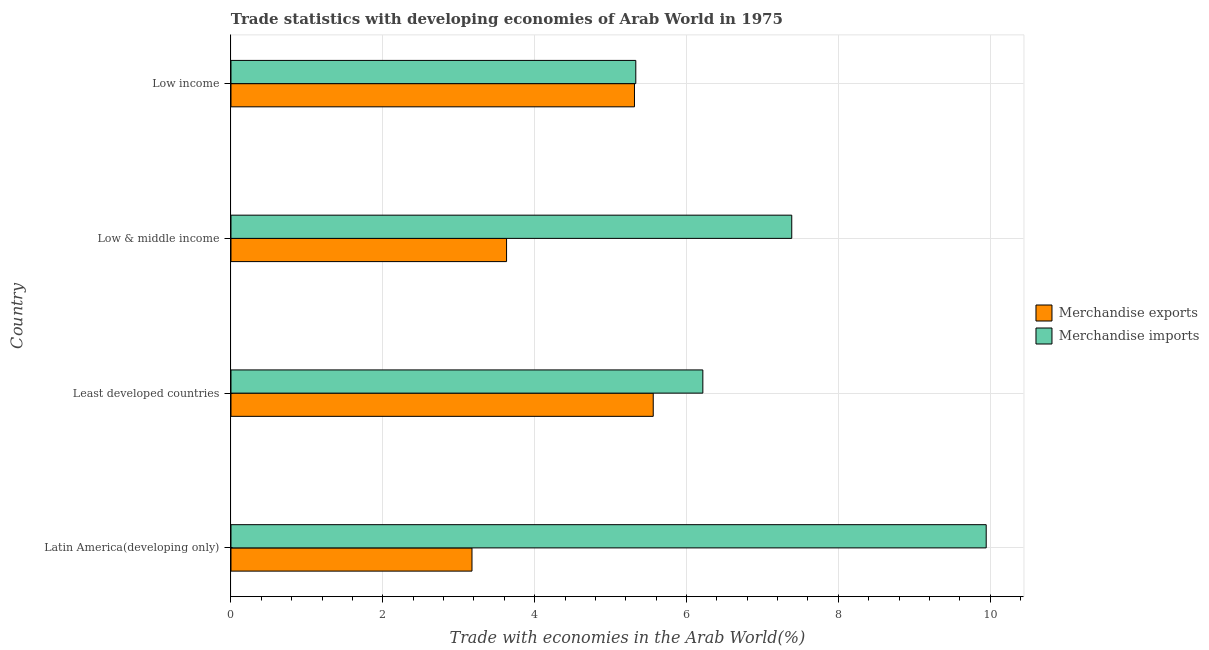How many groups of bars are there?
Your response must be concise. 4. Are the number of bars per tick equal to the number of legend labels?
Keep it short and to the point. Yes. Are the number of bars on each tick of the Y-axis equal?
Offer a terse response. Yes. How many bars are there on the 2nd tick from the bottom?
Give a very brief answer. 2. What is the label of the 4th group of bars from the top?
Provide a succinct answer. Latin America(developing only). In how many cases, is the number of bars for a given country not equal to the number of legend labels?
Provide a succinct answer. 0. What is the merchandise imports in Least developed countries?
Your answer should be very brief. 6.22. Across all countries, what is the maximum merchandise exports?
Provide a succinct answer. 5.56. Across all countries, what is the minimum merchandise imports?
Your response must be concise. 5.33. In which country was the merchandise imports maximum?
Offer a very short reply. Latin America(developing only). In which country was the merchandise exports minimum?
Your answer should be very brief. Latin America(developing only). What is the total merchandise exports in the graph?
Ensure brevity in your answer.  17.68. What is the difference between the merchandise exports in Latin America(developing only) and that in Least developed countries?
Your response must be concise. -2.39. What is the difference between the merchandise imports in Least developed countries and the merchandise exports in Latin America(developing only)?
Give a very brief answer. 3.04. What is the average merchandise exports per country?
Your answer should be compact. 4.42. What is the difference between the merchandise exports and merchandise imports in Latin America(developing only)?
Make the answer very short. -6.77. In how many countries, is the merchandise imports greater than 3.6 %?
Offer a terse response. 4. What is the ratio of the merchandise exports in Latin America(developing only) to that in Least developed countries?
Ensure brevity in your answer.  0.57. Is the merchandise exports in Least developed countries less than that in Low & middle income?
Your answer should be compact. No. What is the difference between the highest and the second highest merchandise exports?
Offer a terse response. 0.25. What is the difference between the highest and the lowest merchandise imports?
Your response must be concise. 4.62. Is the sum of the merchandise imports in Latin America(developing only) and Low income greater than the maximum merchandise exports across all countries?
Provide a succinct answer. Yes. How many bars are there?
Your response must be concise. 8. What is the difference between two consecutive major ticks on the X-axis?
Your answer should be very brief. 2. Where does the legend appear in the graph?
Ensure brevity in your answer.  Center right. What is the title of the graph?
Give a very brief answer. Trade statistics with developing economies of Arab World in 1975. What is the label or title of the X-axis?
Give a very brief answer. Trade with economies in the Arab World(%). What is the Trade with economies in the Arab World(%) of Merchandise exports in Latin America(developing only)?
Ensure brevity in your answer.  3.17. What is the Trade with economies in the Arab World(%) of Merchandise imports in Latin America(developing only)?
Make the answer very short. 9.95. What is the Trade with economies in the Arab World(%) of Merchandise exports in Least developed countries?
Give a very brief answer. 5.56. What is the Trade with economies in the Arab World(%) in Merchandise imports in Least developed countries?
Your response must be concise. 6.22. What is the Trade with economies in the Arab World(%) of Merchandise exports in Low & middle income?
Your response must be concise. 3.63. What is the Trade with economies in the Arab World(%) of Merchandise imports in Low & middle income?
Your answer should be compact. 7.39. What is the Trade with economies in the Arab World(%) of Merchandise exports in Low income?
Your answer should be very brief. 5.31. What is the Trade with economies in the Arab World(%) in Merchandise imports in Low income?
Offer a very short reply. 5.33. Across all countries, what is the maximum Trade with economies in the Arab World(%) in Merchandise exports?
Your answer should be compact. 5.56. Across all countries, what is the maximum Trade with economies in the Arab World(%) in Merchandise imports?
Your answer should be compact. 9.95. Across all countries, what is the minimum Trade with economies in the Arab World(%) of Merchandise exports?
Ensure brevity in your answer.  3.17. Across all countries, what is the minimum Trade with economies in the Arab World(%) of Merchandise imports?
Give a very brief answer. 5.33. What is the total Trade with economies in the Arab World(%) in Merchandise exports in the graph?
Ensure brevity in your answer.  17.68. What is the total Trade with economies in the Arab World(%) of Merchandise imports in the graph?
Provide a succinct answer. 28.88. What is the difference between the Trade with economies in the Arab World(%) of Merchandise exports in Latin America(developing only) and that in Least developed countries?
Make the answer very short. -2.39. What is the difference between the Trade with economies in the Arab World(%) in Merchandise imports in Latin America(developing only) and that in Least developed countries?
Offer a terse response. 3.73. What is the difference between the Trade with economies in the Arab World(%) in Merchandise exports in Latin America(developing only) and that in Low & middle income?
Your answer should be very brief. -0.46. What is the difference between the Trade with economies in the Arab World(%) of Merchandise imports in Latin America(developing only) and that in Low & middle income?
Provide a succinct answer. 2.56. What is the difference between the Trade with economies in the Arab World(%) in Merchandise exports in Latin America(developing only) and that in Low income?
Your answer should be compact. -2.14. What is the difference between the Trade with economies in the Arab World(%) of Merchandise imports in Latin America(developing only) and that in Low income?
Offer a very short reply. 4.62. What is the difference between the Trade with economies in the Arab World(%) of Merchandise exports in Least developed countries and that in Low & middle income?
Keep it short and to the point. 1.93. What is the difference between the Trade with economies in the Arab World(%) in Merchandise imports in Least developed countries and that in Low & middle income?
Your response must be concise. -1.17. What is the difference between the Trade with economies in the Arab World(%) in Merchandise exports in Least developed countries and that in Low income?
Provide a short and direct response. 0.25. What is the difference between the Trade with economies in the Arab World(%) in Merchandise imports in Least developed countries and that in Low income?
Offer a very short reply. 0.88. What is the difference between the Trade with economies in the Arab World(%) in Merchandise exports in Low & middle income and that in Low income?
Your response must be concise. -1.68. What is the difference between the Trade with economies in the Arab World(%) in Merchandise imports in Low & middle income and that in Low income?
Offer a very short reply. 2.05. What is the difference between the Trade with economies in the Arab World(%) in Merchandise exports in Latin America(developing only) and the Trade with economies in the Arab World(%) in Merchandise imports in Least developed countries?
Your answer should be compact. -3.04. What is the difference between the Trade with economies in the Arab World(%) in Merchandise exports in Latin America(developing only) and the Trade with economies in the Arab World(%) in Merchandise imports in Low & middle income?
Offer a very short reply. -4.21. What is the difference between the Trade with economies in the Arab World(%) in Merchandise exports in Latin America(developing only) and the Trade with economies in the Arab World(%) in Merchandise imports in Low income?
Offer a very short reply. -2.16. What is the difference between the Trade with economies in the Arab World(%) of Merchandise exports in Least developed countries and the Trade with economies in the Arab World(%) of Merchandise imports in Low & middle income?
Give a very brief answer. -1.82. What is the difference between the Trade with economies in the Arab World(%) in Merchandise exports in Least developed countries and the Trade with economies in the Arab World(%) in Merchandise imports in Low income?
Keep it short and to the point. 0.23. What is the difference between the Trade with economies in the Arab World(%) in Merchandise exports in Low & middle income and the Trade with economies in the Arab World(%) in Merchandise imports in Low income?
Offer a terse response. -1.7. What is the average Trade with economies in the Arab World(%) of Merchandise exports per country?
Ensure brevity in your answer.  4.42. What is the average Trade with economies in the Arab World(%) in Merchandise imports per country?
Provide a succinct answer. 7.22. What is the difference between the Trade with economies in the Arab World(%) of Merchandise exports and Trade with economies in the Arab World(%) of Merchandise imports in Latin America(developing only)?
Keep it short and to the point. -6.77. What is the difference between the Trade with economies in the Arab World(%) in Merchandise exports and Trade with economies in the Arab World(%) in Merchandise imports in Least developed countries?
Provide a succinct answer. -0.65. What is the difference between the Trade with economies in the Arab World(%) in Merchandise exports and Trade with economies in the Arab World(%) in Merchandise imports in Low & middle income?
Give a very brief answer. -3.76. What is the difference between the Trade with economies in the Arab World(%) in Merchandise exports and Trade with economies in the Arab World(%) in Merchandise imports in Low income?
Your answer should be very brief. -0.02. What is the ratio of the Trade with economies in the Arab World(%) in Merchandise exports in Latin America(developing only) to that in Least developed countries?
Give a very brief answer. 0.57. What is the ratio of the Trade with economies in the Arab World(%) in Merchandise imports in Latin America(developing only) to that in Least developed countries?
Ensure brevity in your answer.  1.6. What is the ratio of the Trade with economies in the Arab World(%) in Merchandise exports in Latin America(developing only) to that in Low & middle income?
Give a very brief answer. 0.87. What is the ratio of the Trade with economies in the Arab World(%) of Merchandise imports in Latin America(developing only) to that in Low & middle income?
Ensure brevity in your answer.  1.35. What is the ratio of the Trade with economies in the Arab World(%) in Merchandise exports in Latin America(developing only) to that in Low income?
Make the answer very short. 0.6. What is the ratio of the Trade with economies in the Arab World(%) of Merchandise imports in Latin America(developing only) to that in Low income?
Make the answer very short. 1.87. What is the ratio of the Trade with economies in the Arab World(%) in Merchandise exports in Least developed countries to that in Low & middle income?
Ensure brevity in your answer.  1.53. What is the ratio of the Trade with economies in the Arab World(%) of Merchandise imports in Least developed countries to that in Low & middle income?
Keep it short and to the point. 0.84. What is the ratio of the Trade with economies in the Arab World(%) of Merchandise exports in Least developed countries to that in Low income?
Your answer should be compact. 1.05. What is the ratio of the Trade with economies in the Arab World(%) of Merchandise imports in Least developed countries to that in Low income?
Keep it short and to the point. 1.17. What is the ratio of the Trade with economies in the Arab World(%) of Merchandise exports in Low & middle income to that in Low income?
Your response must be concise. 0.68. What is the ratio of the Trade with economies in the Arab World(%) of Merchandise imports in Low & middle income to that in Low income?
Offer a terse response. 1.39. What is the difference between the highest and the second highest Trade with economies in the Arab World(%) in Merchandise exports?
Provide a short and direct response. 0.25. What is the difference between the highest and the second highest Trade with economies in the Arab World(%) in Merchandise imports?
Give a very brief answer. 2.56. What is the difference between the highest and the lowest Trade with economies in the Arab World(%) in Merchandise exports?
Offer a very short reply. 2.39. What is the difference between the highest and the lowest Trade with economies in the Arab World(%) of Merchandise imports?
Provide a succinct answer. 4.62. 